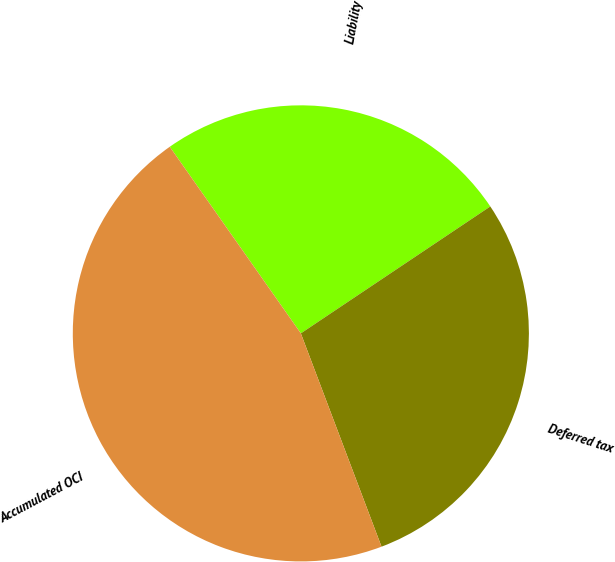Convert chart. <chart><loc_0><loc_0><loc_500><loc_500><pie_chart><fcel>Liability<fcel>Deferred tax<fcel>Accumulated OCI<nl><fcel>25.35%<fcel>28.64%<fcel>46.01%<nl></chart> 